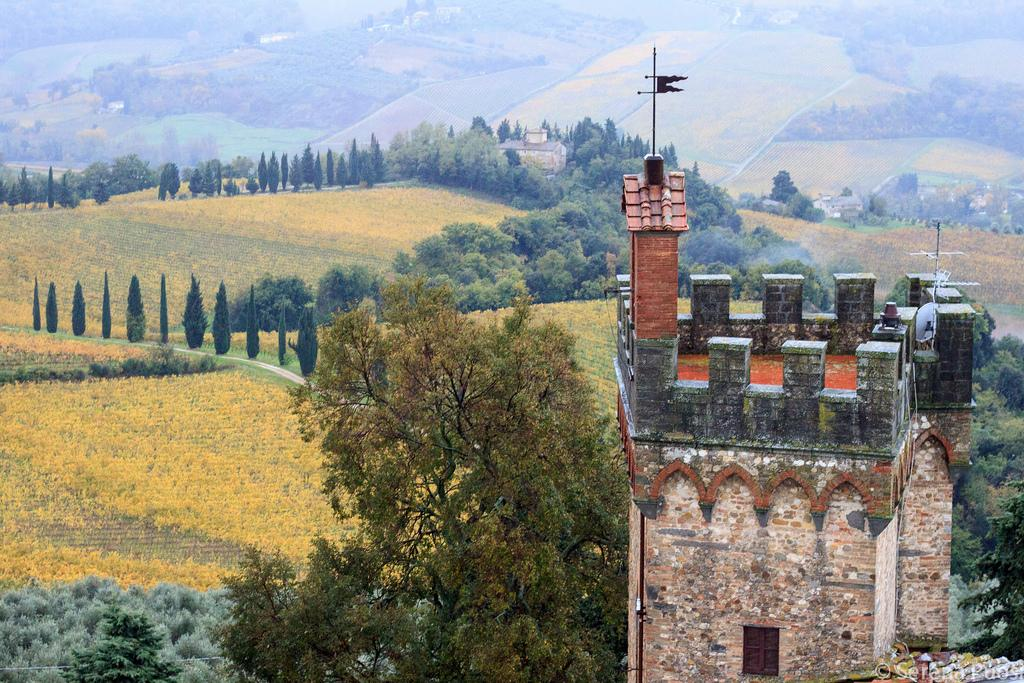What type of structures can be seen in the image? There are buildings in the image. What other natural elements are present in the image? There are trees and fields in the image. Can you describe the flag in the image? There is a flag on top of a building in the image. Where can text be found in the image? Text can be found at the bottom right of the image. What type of apparel is being worn by the trees in the image? There are no people or apparel present in the image, as it features buildings, trees, fields, a flag, and text. 